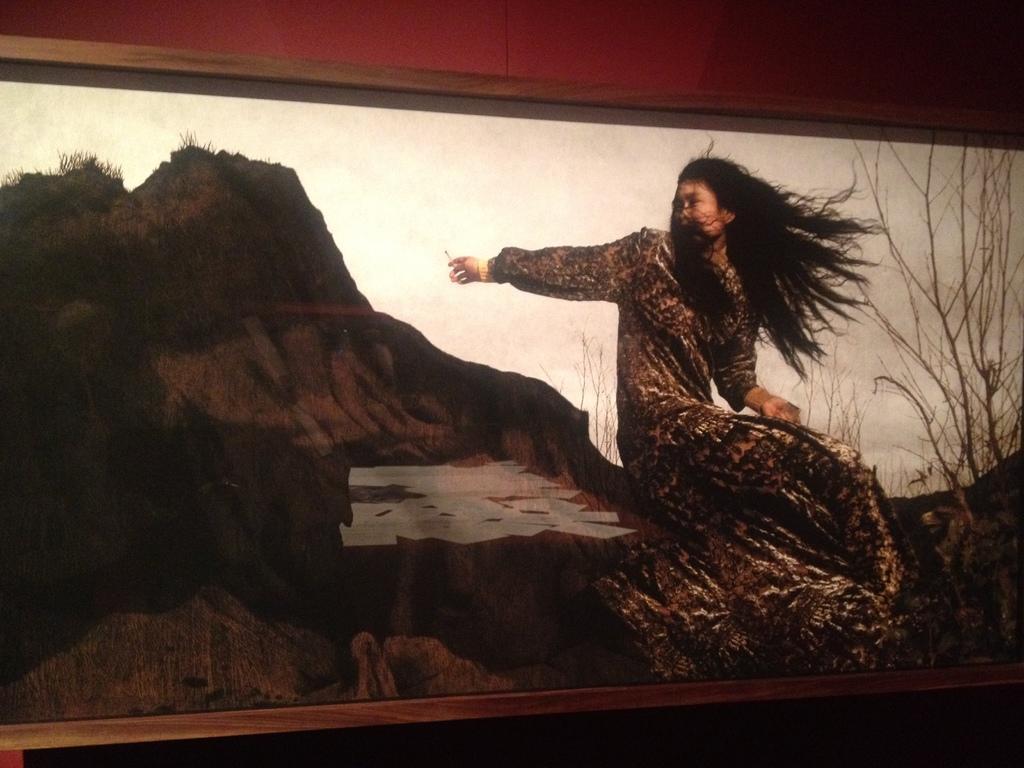Can you describe this image briefly? In this image I can see a photo frame and on it I can see a woman and few trees. 